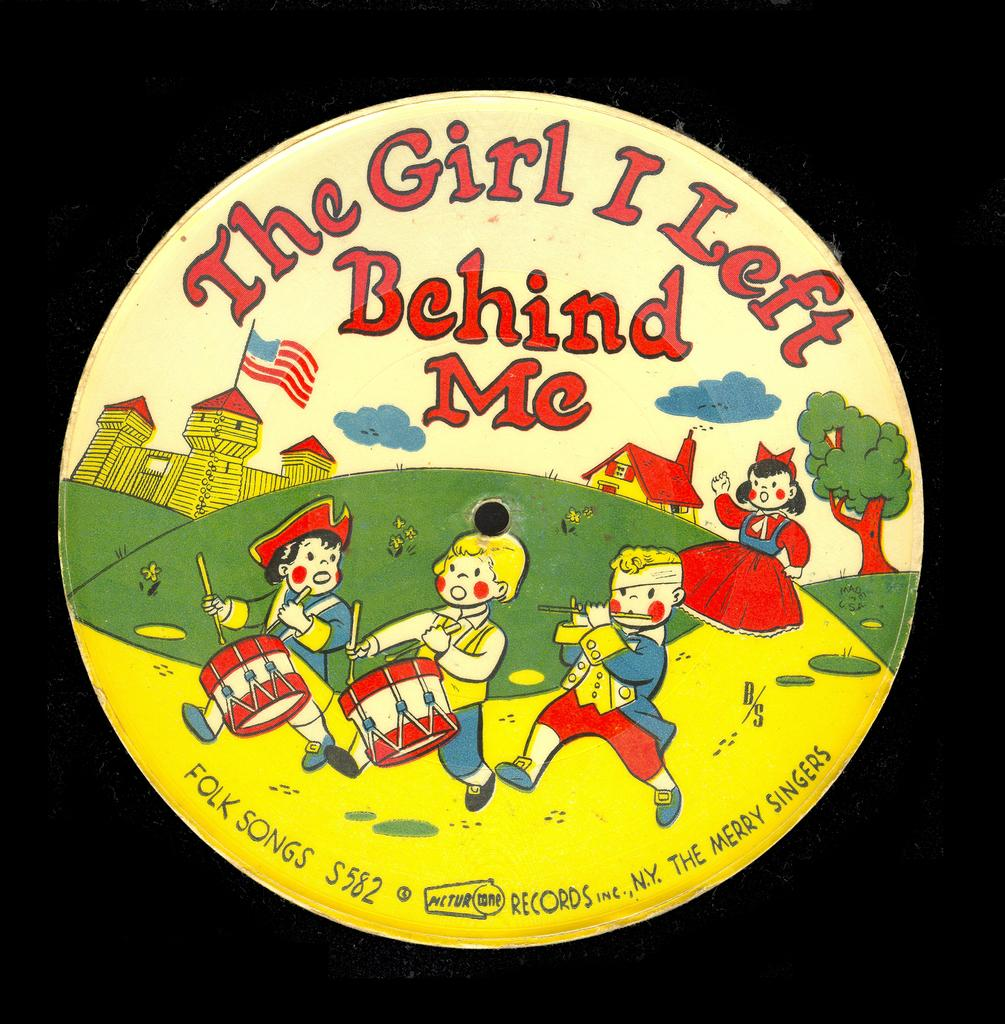What type of images are present in the image? There are cartoon pictures in the image. What is the shape of the board with text on it? The board with text on it is spherical. Where is the spherical board placed in the image? The spherical board is placed on a surface. What type of stage is visible in the image? There is no stage present in the image. Is there a hose connected to the spherical board in the image? There is no hose connected to the spherical board in the image. 